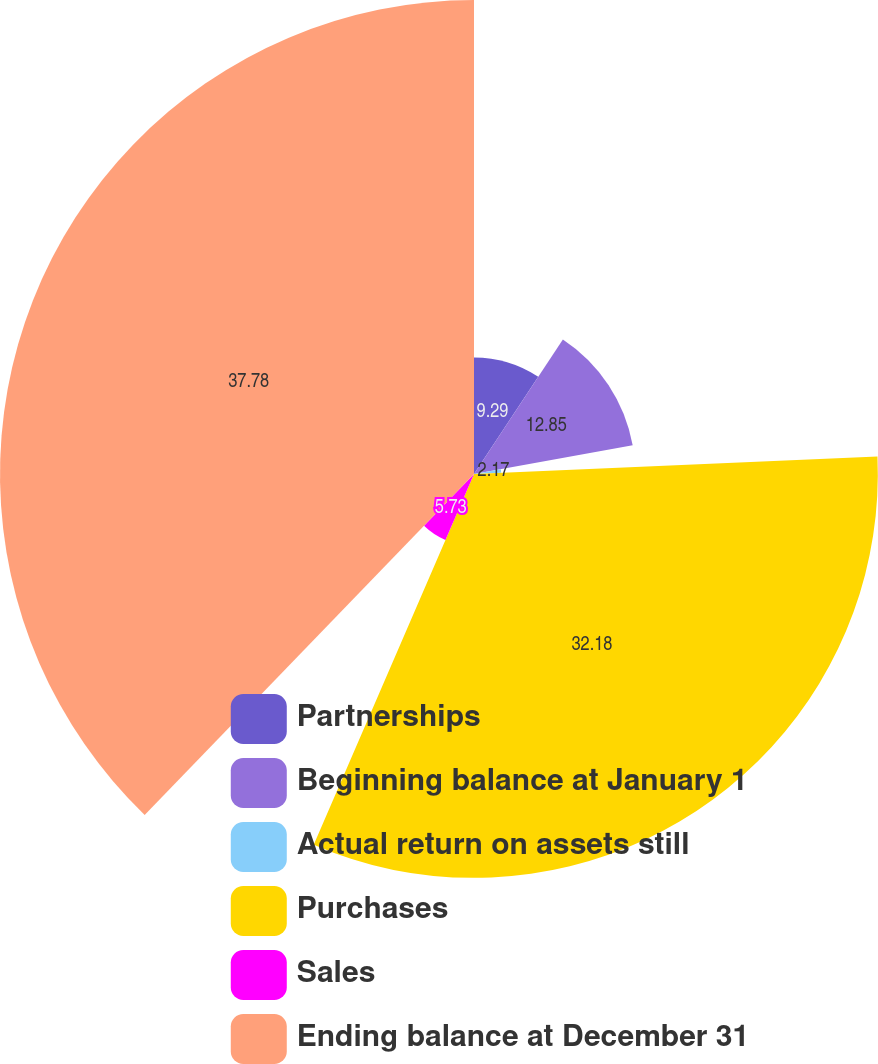Convert chart. <chart><loc_0><loc_0><loc_500><loc_500><pie_chart><fcel>Partnerships<fcel>Beginning balance at January 1<fcel>Actual return on assets still<fcel>Purchases<fcel>Sales<fcel>Ending balance at December 31<nl><fcel>9.29%<fcel>12.85%<fcel>2.17%<fcel>32.18%<fcel>5.73%<fcel>37.77%<nl></chart> 